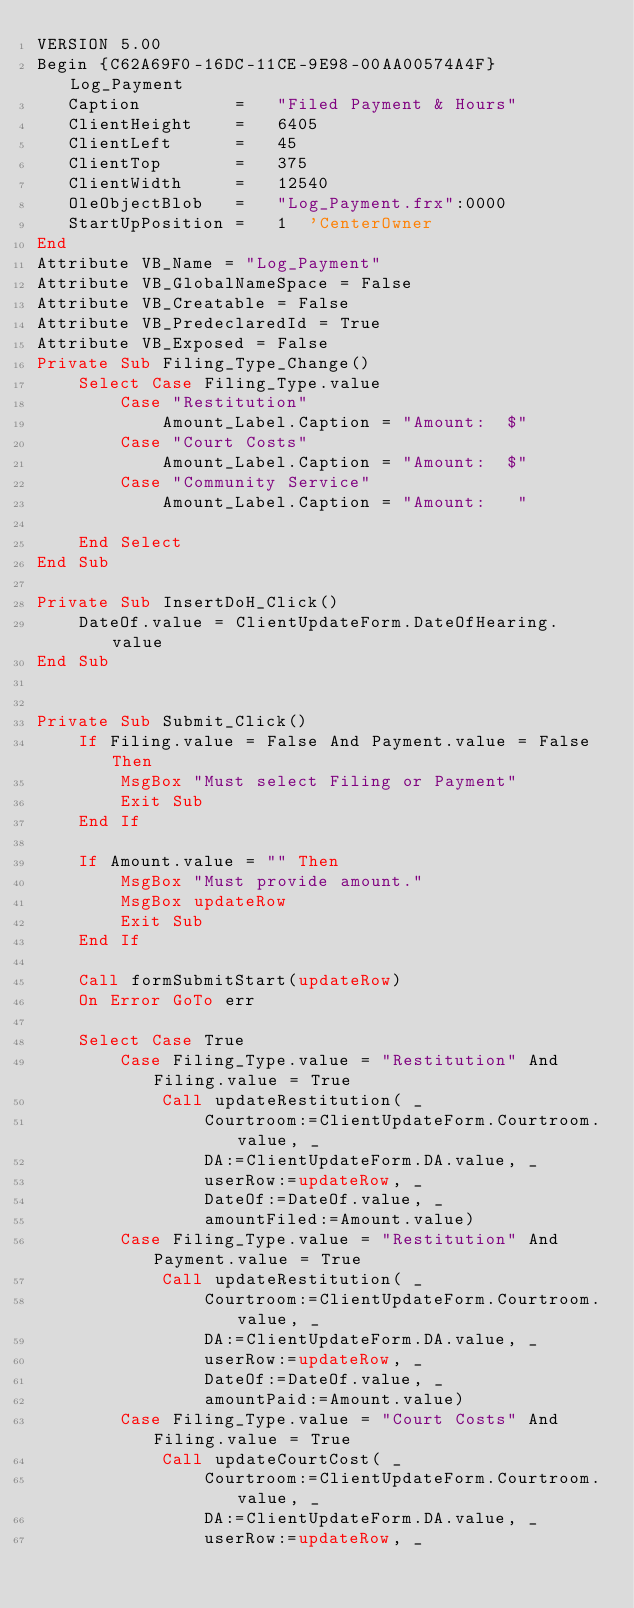Convert code to text. <code><loc_0><loc_0><loc_500><loc_500><_VisualBasic_>VERSION 5.00
Begin {C62A69F0-16DC-11CE-9E98-00AA00574A4F} Log_Payment 
   Caption         =   "Filed Payment & Hours"
   ClientHeight    =   6405
   ClientLeft      =   45
   ClientTop       =   375
   ClientWidth     =   12540
   OleObjectBlob   =   "Log_Payment.frx":0000
   StartUpPosition =   1  'CenterOwner
End
Attribute VB_Name = "Log_Payment"
Attribute VB_GlobalNameSpace = False
Attribute VB_Creatable = False
Attribute VB_PredeclaredId = True
Attribute VB_Exposed = False
Private Sub Filing_Type_Change()
    Select Case Filing_Type.value
        Case "Restitution"
            Amount_Label.Caption = "Amount:  $"
        Case "Court Costs"
            Amount_Label.Caption = "Amount:  $"
        Case "Community Service"
            Amount_Label.Caption = "Amount:   "
    
    End Select
End Sub

Private Sub InsertDoH_Click()
    DateOf.value = ClientUpdateForm.DateOfHearing.value
End Sub


Private Sub Submit_Click()
    If Filing.value = False And Payment.value = False Then
        MsgBox "Must select Filing or Payment"
        Exit Sub
    End If
    
    If Amount.value = "" Then
        MsgBox "Must provide amount."
        MsgBox updateRow
        Exit Sub
    End If
    
    Call formSubmitStart(updateRow)
    On Error GoTo err
    
    Select Case True
        Case Filing_Type.value = "Restitution" And Filing.value = True
            Call updateRestitution( _
                Courtroom:=ClientUpdateForm.Courtroom.value, _
                DA:=ClientUpdateForm.DA.value, _
                userRow:=updateRow, _
                DateOf:=DateOf.value, _
                amountFiled:=Amount.value)
        Case Filing_Type.value = "Restitution" And Payment.value = True
            Call updateRestitution( _
                Courtroom:=ClientUpdateForm.Courtroom.value, _
                DA:=ClientUpdateForm.DA.value, _
                userRow:=updateRow, _
                DateOf:=DateOf.value, _
                amountPaid:=Amount.value)
        Case Filing_Type.value = "Court Costs" And Filing.value = True
            Call updateCourtCost( _
                Courtroom:=ClientUpdateForm.Courtroom.value, _
                DA:=ClientUpdateForm.DA.value, _
                userRow:=updateRow, _</code> 